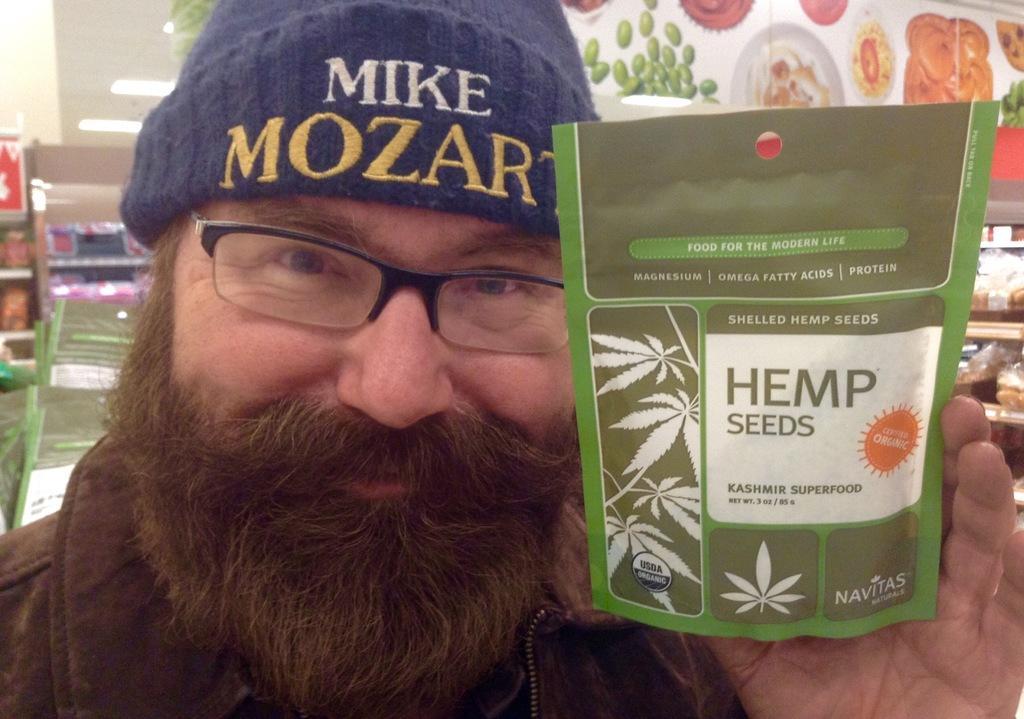Please provide a concise description of this image. In this image, we can see a man wearing cap and glasses and holding a packet in his hand. In the background, we can see food items. 